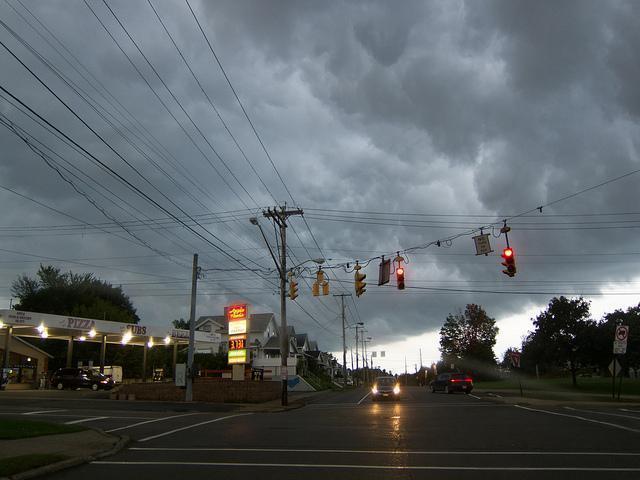What type of station is in view?
Indicate the correct response by choosing from the four available options to answer the question.
Options: Bus, gas, fire, train. Gas. 